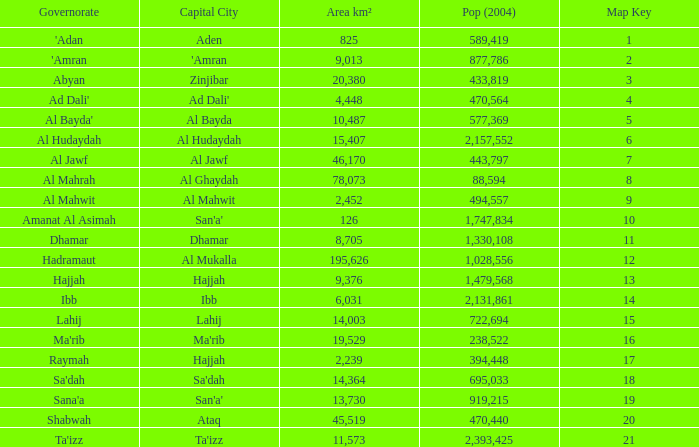Find the aggregate pop (2004) in al mahrah governorate with a size smaller than 78,073 km²? None. 